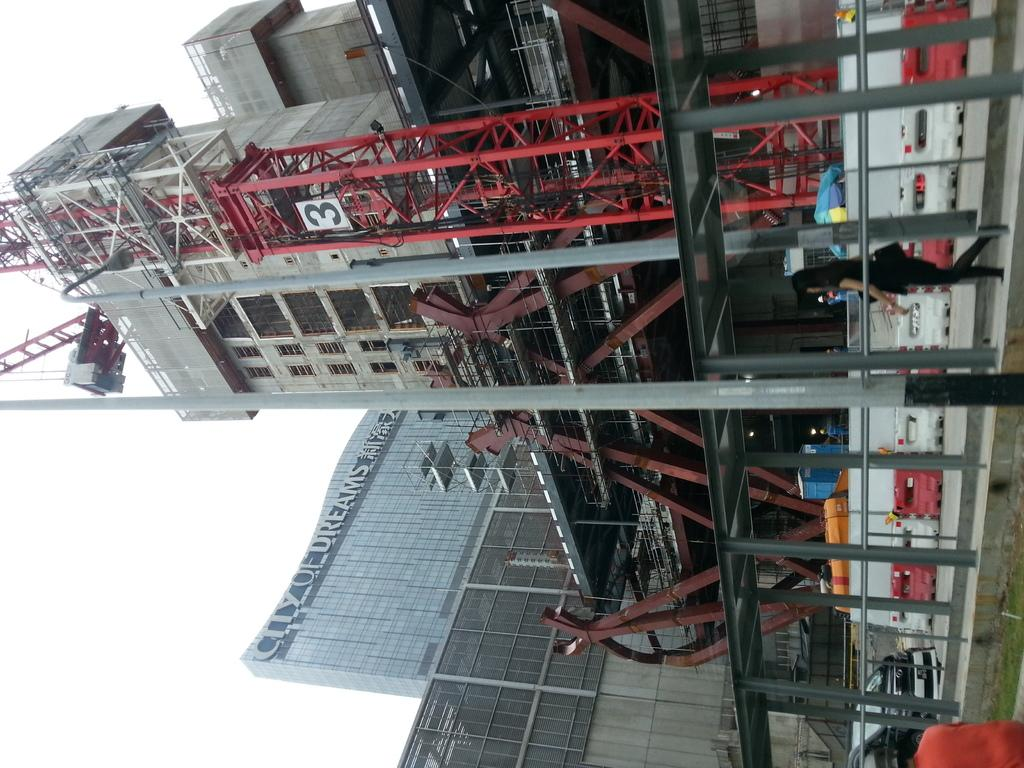What is the main subject in the foreground of the image? There is a crane in the foreground of the image. What else can be seen in the foreground of the image? There is other equipment visible in the foreground of the image. What is visible in the background of the image? There are buildings visible behind the crane. Can you describe the woman in the image? There is a woman walking on a path in front of the crane. What does the woman start talking about as she approaches the crane? There is no indication in the image that the woman is talking or approaching the crane, so it cannot be determined from the picture. 